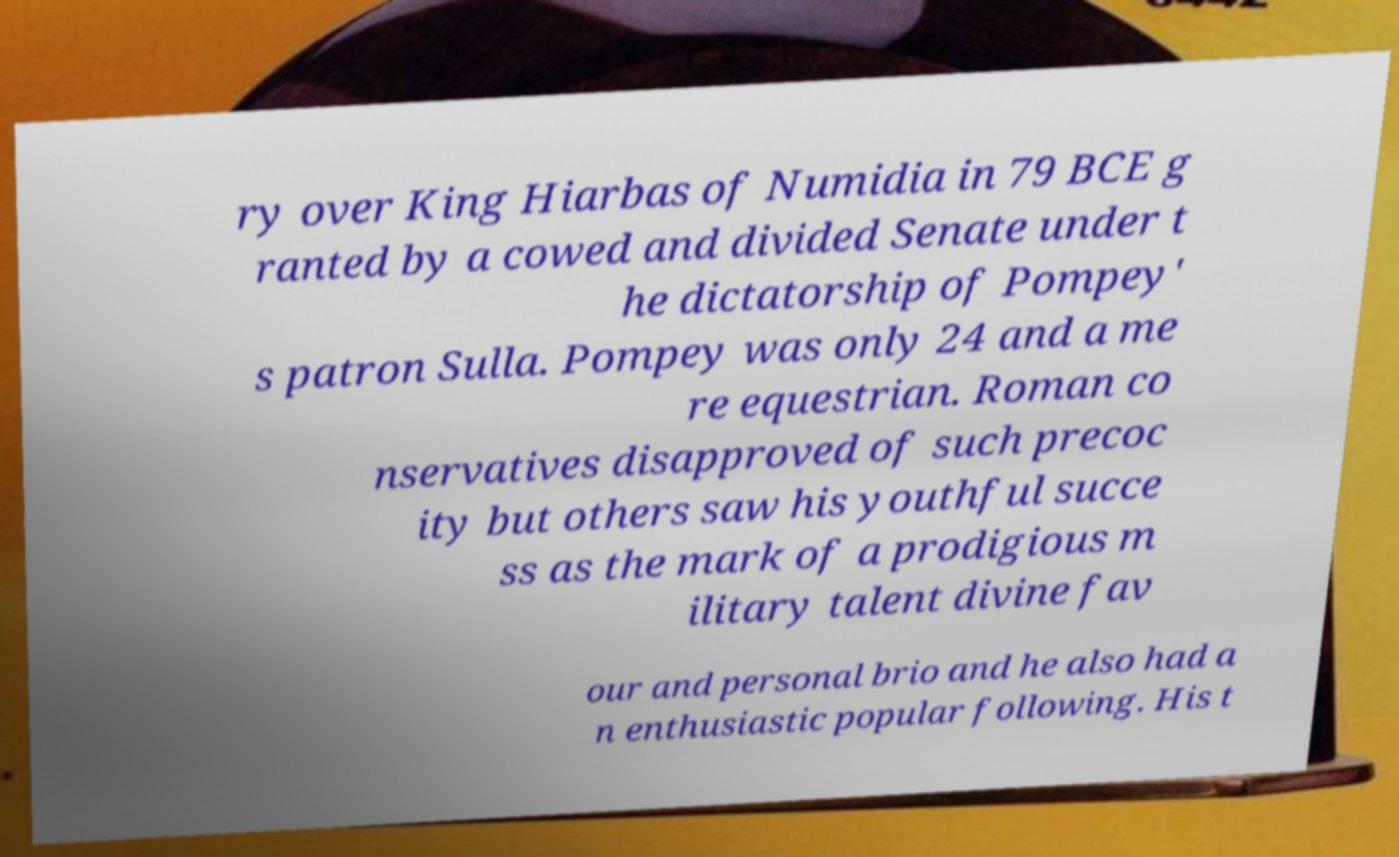For documentation purposes, I need the text within this image transcribed. Could you provide that? ry over King Hiarbas of Numidia in 79 BCE g ranted by a cowed and divided Senate under t he dictatorship of Pompey' s patron Sulla. Pompey was only 24 and a me re equestrian. Roman co nservatives disapproved of such precoc ity but others saw his youthful succe ss as the mark of a prodigious m ilitary talent divine fav our and personal brio and he also had a n enthusiastic popular following. His t 